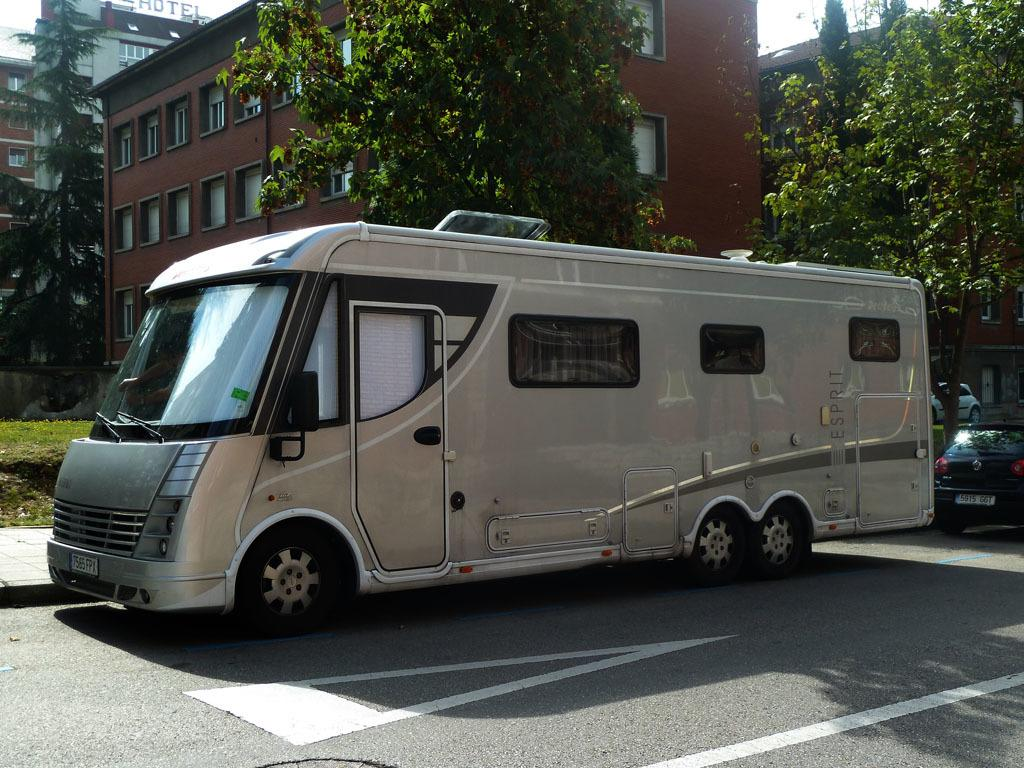What is the main subject of the image? There is a vehicle on the road in the image. What can be seen in the background of the image? Trees, buildings, and the sky are visible in the background of the image. Where is the playground located in the image? There is no playground present in the image. How do the people in the image say good-bye to each other? There are no people visible in the image, so it is not possible to determine how they might say good-bye. 